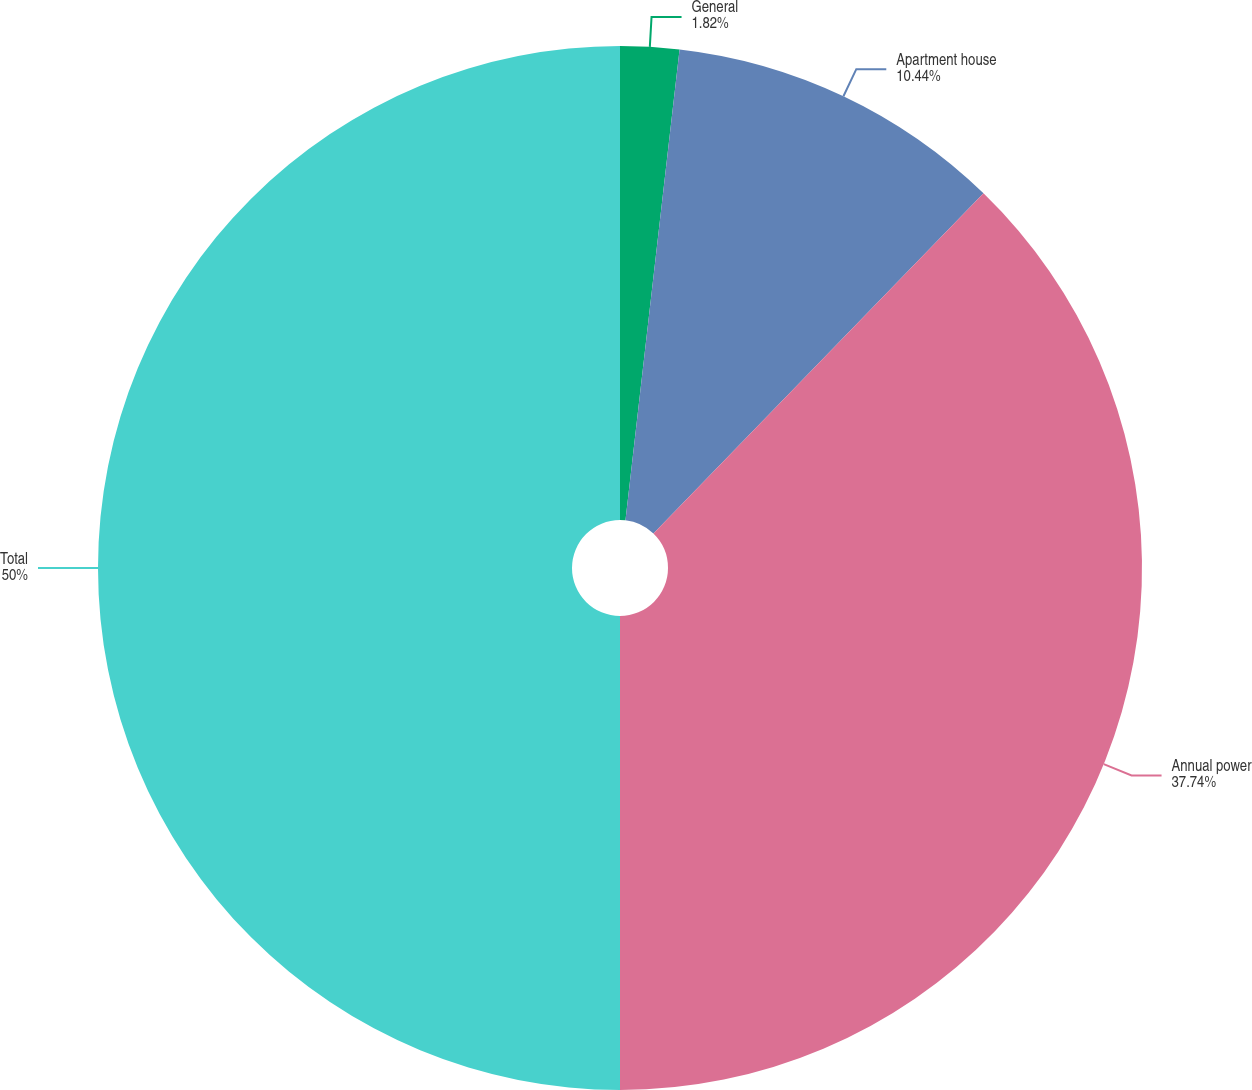Convert chart. <chart><loc_0><loc_0><loc_500><loc_500><pie_chart><fcel>General<fcel>Apartment house<fcel>Annual power<fcel>Total<nl><fcel>1.82%<fcel>10.44%<fcel>37.74%<fcel>50.0%<nl></chart> 